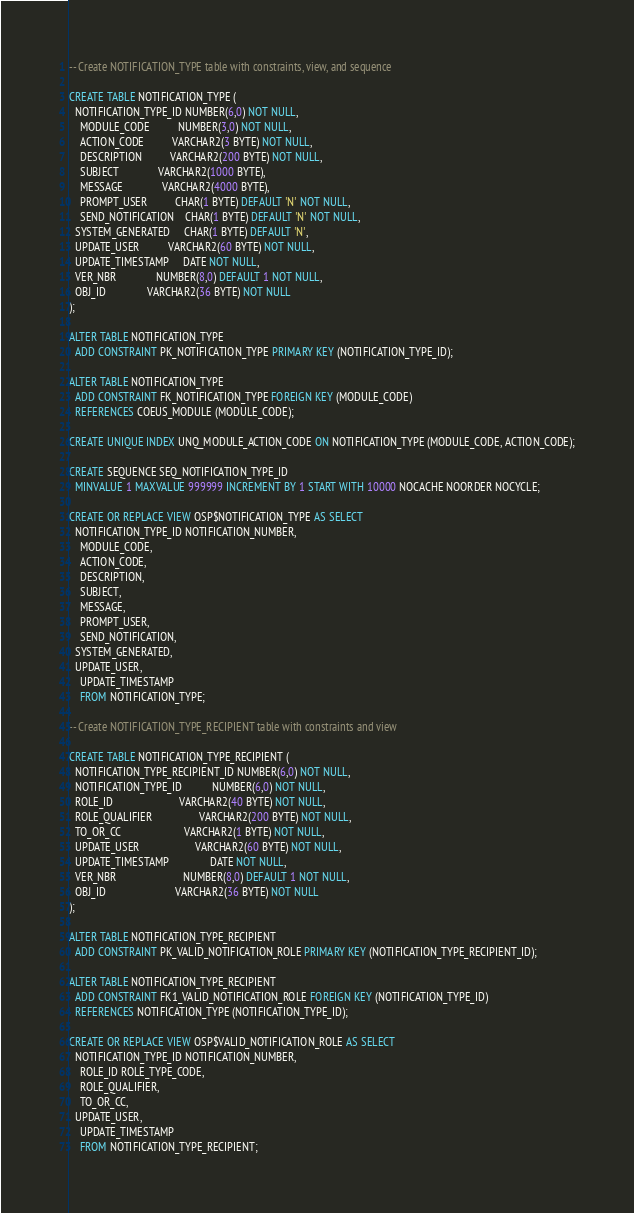Convert code to text. <code><loc_0><loc_0><loc_500><loc_500><_SQL_>-- Create NOTIFICATION_TYPE table with constraints, view, and sequence

CREATE TABLE NOTIFICATION_TYPE (
  NOTIFICATION_TYPE_ID NUMBER(6,0) NOT NULL, 
	MODULE_CODE          NUMBER(3,0) NOT NULL, 
	ACTION_CODE          VARCHAR2(3 BYTE) NOT NULL, 
	DESCRIPTION          VARCHAR2(200 BYTE) NOT NULL, 
	SUBJECT              VARCHAR2(1000 BYTE), 
	MESSAGE              VARCHAR2(4000 BYTE), 
	PROMPT_USER          CHAR(1 BYTE) DEFAULT 'N' NOT NULL, 
	SEND_NOTIFICATION    CHAR(1 BYTE) DEFAULT 'N' NOT NULL,
  SYSTEM_GENERATED     CHAR(1 BYTE) DEFAULT 'N',
  UPDATE_USER          VARCHAR2(60 BYTE) NOT NULL, 
  UPDATE_TIMESTAMP     DATE NOT NULL,
  VER_NBR              NUMBER(8,0) DEFAULT 1 NOT NULL, 
  OBJ_ID               VARCHAR2(36 BYTE) NOT NULL
);
 
ALTER TABLE NOTIFICATION_TYPE 
  ADD CONSTRAINT PK_NOTIFICATION_TYPE PRIMARY KEY (NOTIFICATION_TYPE_ID);

ALTER TABLE NOTIFICATION_TYPE
  ADD CONSTRAINT FK_NOTIFICATION_TYPE FOREIGN KEY (MODULE_CODE)
  REFERENCES COEUS_MODULE (MODULE_CODE);

CREATE UNIQUE INDEX UNQ_MODULE_ACTION_CODE ON NOTIFICATION_TYPE (MODULE_CODE, ACTION_CODE);

CREATE SEQUENCE SEQ_NOTIFICATION_TYPE_ID
  MINVALUE 1 MAXVALUE 999999 INCREMENT BY 1 START WITH 10000 NOCACHE NOORDER NOCYCLE;
  
CREATE OR REPLACE VIEW OSP$NOTIFICATION_TYPE AS SELECT
  NOTIFICATION_TYPE_ID NOTIFICATION_NUMBER, 
	MODULE_CODE, 
	ACTION_CODE, 
	DESCRIPTION, 
	SUBJECT, 
	MESSAGE, 
	PROMPT_USER, 
	SEND_NOTIFICATION,
  SYSTEM_GENERATED,
  UPDATE_USER, 
	UPDATE_TIMESTAMP 
	FROM NOTIFICATION_TYPE;
  
-- Create NOTIFICATION_TYPE_RECIPIENT table with constraints and view

CREATE TABLE NOTIFICATION_TYPE_RECIPIENT (
  NOTIFICATION_TYPE_RECIPIENT_ID NUMBER(6,0) NOT NULL,
  NOTIFICATION_TYPE_ID           NUMBER(6,0) NOT NULL,
  ROLE_ID                        VARCHAR2(40 BYTE) NOT NULL,
  ROLE_QUALIFIER                 VARCHAR2(200 BYTE) NOT NULL,
  TO_OR_CC                       VARCHAR2(1 BYTE) NOT NULL,
  UPDATE_USER                    VARCHAR2(60 BYTE) NOT NULL,
  UPDATE_TIMESTAMP               DATE NOT NULL,
  VER_NBR                        NUMBER(8,0) DEFAULT 1 NOT NULL, 
  OBJ_ID                         VARCHAR2(36 BYTE) NOT NULL
);

ALTER TABLE NOTIFICATION_TYPE_RECIPIENT
  ADD CONSTRAINT PK_VALID_NOTIFICATION_ROLE PRIMARY KEY (NOTIFICATION_TYPE_RECIPIENT_ID);

ALTER TABLE NOTIFICATION_TYPE_RECIPIENT
  ADD CONSTRAINT FK1_VALID_NOTIFICATION_ROLE FOREIGN KEY (NOTIFICATION_TYPE_ID)
  REFERENCES NOTIFICATION_TYPE (NOTIFICATION_TYPE_ID);

CREATE OR REPLACE VIEW OSP$VALID_NOTIFICATION_ROLE AS SELECT
  NOTIFICATION_TYPE_ID NOTIFICATION_NUMBER, 
	ROLE_ID ROLE_TYPE_CODE,
	ROLE_QUALIFIER, 
	TO_OR_CC, 
  UPDATE_USER, 
	UPDATE_TIMESTAMP 
	FROM NOTIFICATION_TYPE_RECIPIENT;</code> 